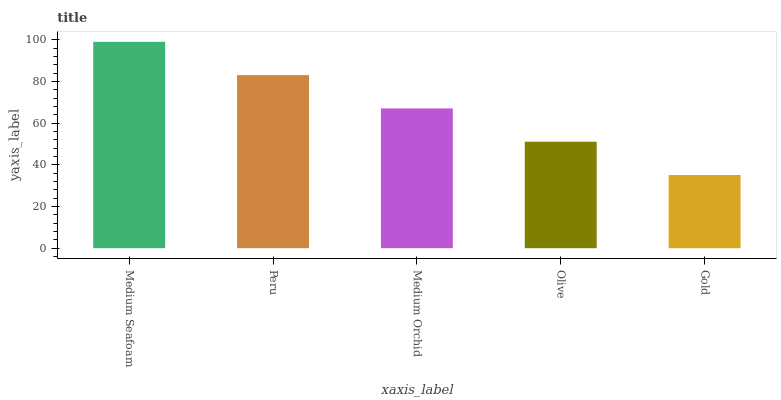Is Peru the minimum?
Answer yes or no. No. Is Peru the maximum?
Answer yes or no. No. Is Medium Seafoam greater than Peru?
Answer yes or no. Yes. Is Peru less than Medium Seafoam?
Answer yes or no. Yes. Is Peru greater than Medium Seafoam?
Answer yes or no. No. Is Medium Seafoam less than Peru?
Answer yes or no. No. Is Medium Orchid the high median?
Answer yes or no. Yes. Is Medium Orchid the low median?
Answer yes or no. Yes. Is Peru the high median?
Answer yes or no. No. Is Peru the low median?
Answer yes or no. No. 